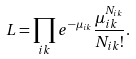<formula> <loc_0><loc_0><loc_500><loc_500>L = \prod _ { i k } e ^ { - \mu _ { i k } } \frac { \mu _ { i k } ^ { N _ { i k } } } { N _ { i k } ! } .</formula> 